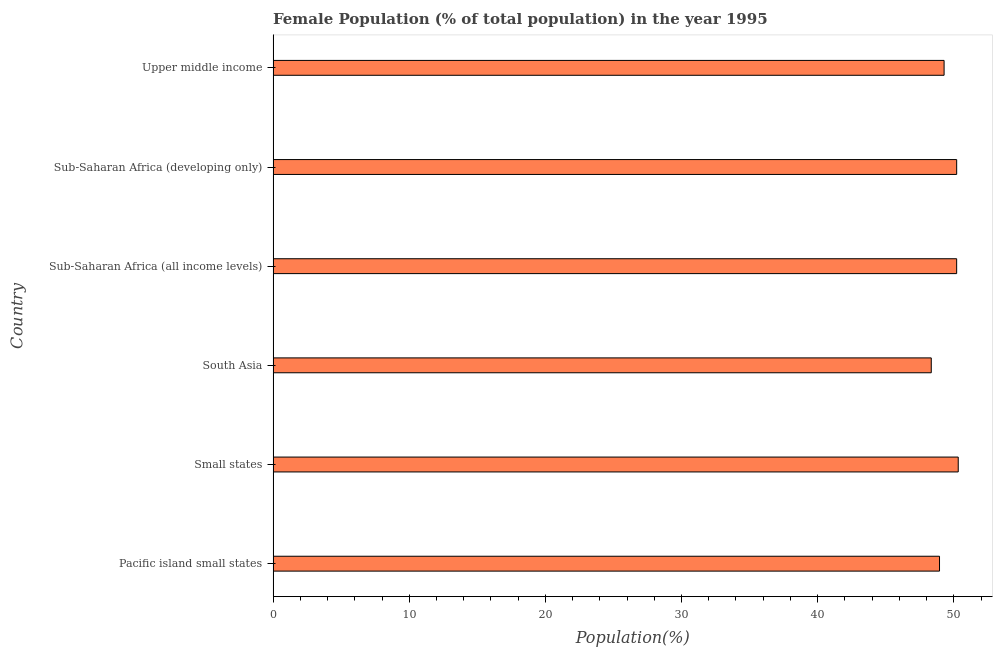Does the graph contain any zero values?
Your response must be concise. No. What is the title of the graph?
Make the answer very short. Female Population (% of total population) in the year 1995. What is the label or title of the X-axis?
Give a very brief answer. Population(%). What is the label or title of the Y-axis?
Your response must be concise. Country. What is the female population in South Asia?
Give a very brief answer. 48.35. Across all countries, what is the maximum female population?
Your answer should be compact. 50.33. Across all countries, what is the minimum female population?
Provide a succinct answer. 48.35. In which country was the female population maximum?
Make the answer very short. Small states. What is the sum of the female population?
Ensure brevity in your answer.  297.33. What is the difference between the female population in South Asia and Upper middle income?
Ensure brevity in your answer.  -0.94. What is the average female population per country?
Your answer should be very brief. 49.56. What is the median female population?
Your answer should be compact. 49.75. In how many countries, is the female population greater than 38 %?
Offer a very short reply. 6. What is the ratio of the female population in Small states to that in South Asia?
Give a very brief answer. 1.04. Is the female population in Pacific island small states less than that in Sub-Saharan Africa (all income levels)?
Offer a very short reply. Yes. Is the difference between the female population in Small states and Sub-Saharan Africa (developing only) greater than the difference between any two countries?
Provide a short and direct response. No. What is the difference between the highest and the second highest female population?
Offer a very short reply. 0.12. Is the sum of the female population in South Asia and Upper middle income greater than the maximum female population across all countries?
Your answer should be very brief. Yes. What is the difference between the highest and the lowest female population?
Offer a very short reply. 1.98. Are all the bars in the graph horizontal?
Your answer should be compact. Yes. How many countries are there in the graph?
Your answer should be very brief. 6. What is the difference between two consecutive major ticks on the X-axis?
Provide a short and direct response. 10. Are the values on the major ticks of X-axis written in scientific E-notation?
Offer a very short reply. No. What is the Population(%) in Pacific island small states?
Provide a succinct answer. 48.95. What is the Population(%) in Small states?
Your answer should be compact. 50.33. What is the Population(%) in South Asia?
Your answer should be very brief. 48.35. What is the Population(%) of Sub-Saharan Africa (all income levels)?
Keep it short and to the point. 50.21. What is the Population(%) in Sub-Saharan Africa (developing only)?
Provide a short and direct response. 50.21. What is the Population(%) of Upper middle income?
Give a very brief answer. 49.29. What is the difference between the Population(%) in Pacific island small states and Small states?
Ensure brevity in your answer.  -1.37. What is the difference between the Population(%) in Pacific island small states and South Asia?
Your answer should be compact. 0.61. What is the difference between the Population(%) in Pacific island small states and Sub-Saharan Africa (all income levels)?
Your answer should be compact. -1.26. What is the difference between the Population(%) in Pacific island small states and Sub-Saharan Africa (developing only)?
Your answer should be very brief. -1.26. What is the difference between the Population(%) in Pacific island small states and Upper middle income?
Give a very brief answer. -0.34. What is the difference between the Population(%) in Small states and South Asia?
Keep it short and to the point. 1.98. What is the difference between the Population(%) in Small states and Sub-Saharan Africa (all income levels)?
Provide a short and direct response. 0.12. What is the difference between the Population(%) in Small states and Sub-Saharan Africa (developing only)?
Give a very brief answer. 0.11. What is the difference between the Population(%) in Small states and Upper middle income?
Give a very brief answer. 1.04. What is the difference between the Population(%) in South Asia and Sub-Saharan Africa (all income levels)?
Your answer should be compact. -1.87. What is the difference between the Population(%) in South Asia and Sub-Saharan Africa (developing only)?
Provide a short and direct response. -1.87. What is the difference between the Population(%) in South Asia and Upper middle income?
Offer a terse response. -0.94. What is the difference between the Population(%) in Sub-Saharan Africa (all income levels) and Sub-Saharan Africa (developing only)?
Ensure brevity in your answer.  -0. What is the difference between the Population(%) in Sub-Saharan Africa (all income levels) and Upper middle income?
Your response must be concise. 0.92. What is the difference between the Population(%) in Sub-Saharan Africa (developing only) and Upper middle income?
Your response must be concise. 0.92. What is the ratio of the Population(%) in Pacific island small states to that in Small states?
Provide a succinct answer. 0.97. What is the ratio of the Population(%) in Pacific island small states to that in South Asia?
Give a very brief answer. 1.01. What is the ratio of the Population(%) in Pacific island small states to that in Sub-Saharan Africa (all income levels)?
Your response must be concise. 0.97. What is the ratio of the Population(%) in Pacific island small states to that in Sub-Saharan Africa (developing only)?
Provide a succinct answer. 0.97. What is the ratio of the Population(%) in Small states to that in South Asia?
Offer a very short reply. 1.04. What is the ratio of the Population(%) in Small states to that in Sub-Saharan Africa (all income levels)?
Your answer should be compact. 1. What is the ratio of the Population(%) in Small states to that in Sub-Saharan Africa (developing only)?
Offer a very short reply. 1. What is the ratio of the Population(%) in Small states to that in Upper middle income?
Keep it short and to the point. 1.02. What is the ratio of the Population(%) in South Asia to that in Upper middle income?
Give a very brief answer. 0.98. What is the ratio of the Population(%) in Sub-Saharan Africa (all income levels) to that in Upper middle income?
Your answer should be compact. 1.02. What is the ratio of the Population(%) in Sub-Saharan Africa (developing only) to that in Upper middle income?
Offer a terse response. 1.02. 